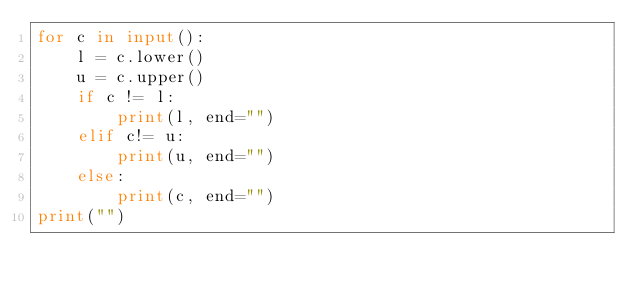<code> <loc_0><loc_0><loc_500><loc_500><_Python_>for c in input():
	l = c.lower()
	u = c.upper()
	if c != l:
		print(l, end="")
	elif c!= u:
		print(u, end="")
	else:
		print(c, end="")
print("")

</code> 